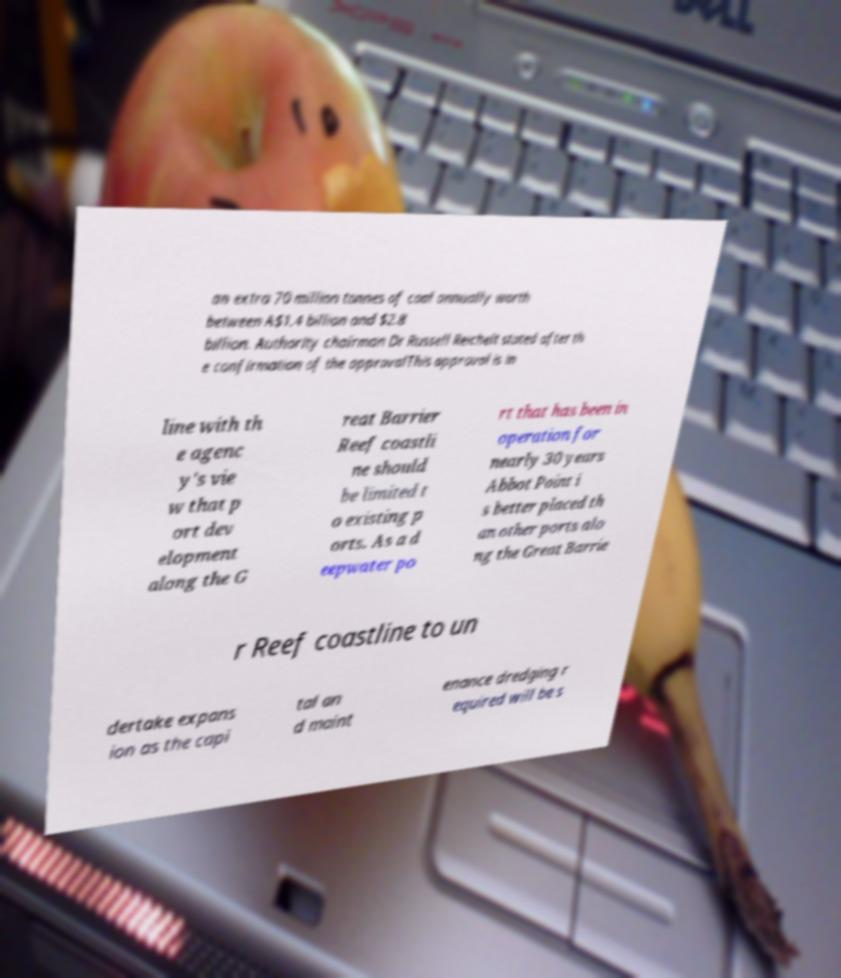I need the written content from this picture converted into text. Can you do that? an extra 70 million tonnes of coal annually worth between A$1.4 billion and $2.8 billion. Authority chairman Dr Russell Reichelt stated after th e confirmation of the approvalThis approval is in line with th e agenc y's vie w that p ort dev elopment along the G reat Barrier Reef coastli ne should be limited t o existing p orts. As a d eepwater po rt that has been in operation for nearly 30 years Abbot Point i s better placed th an other ports alo ng the Great Barrie r Reef coastline to un dertake expans ion as the capi tal an d maint enance dredging r equired will be s 